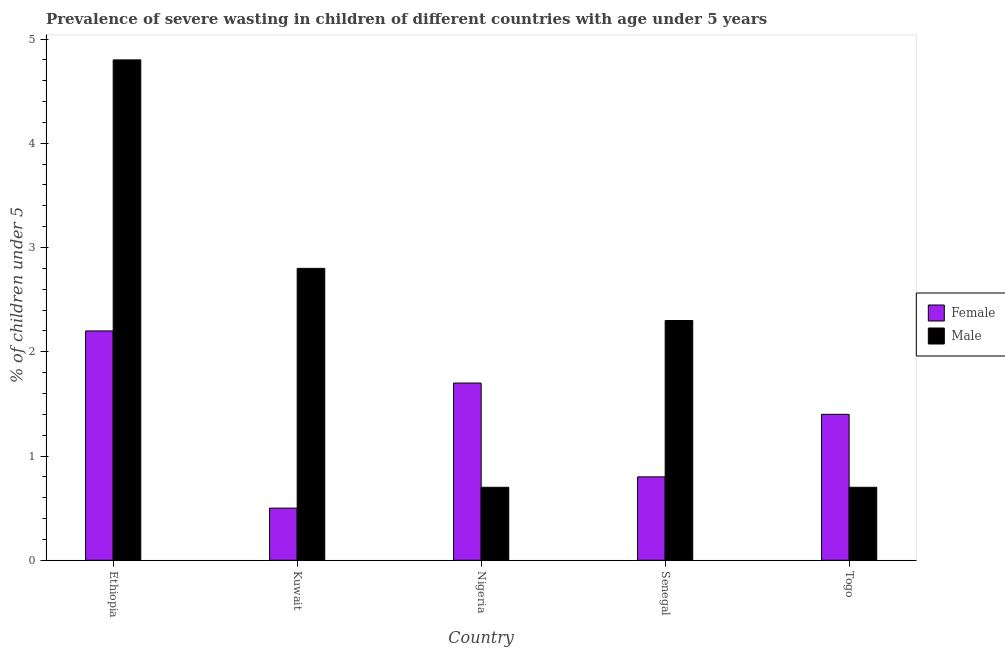How many different coloured bars are there?
Keep it short and to the point. 2. How many groups of bars are there?
Your answer should be compact. 5. Are the number of bars per tick equal to the number of legend labels?
Provide a short and direct response. Yes. How many bars are there on the 4th tick from the left?
Offer a terse response. 2. How many bars are there on the 1st tick from the right?
Provide a short and direct response. 2. What is the label of the 1st group of bars from the left?
Provide a succinct answer. Ethiopia. In how many cases, is the number of bars for a given country not equal to the number of legend labels?
Your answer should be compact. 0. What is the percentage of undernourished male children in Togo?
Your answer should be very brief. 0.7. Across all countries, what is the maximum percentage of undernourished male children?
Make the answer very short. 4.8. Across all countries, what is the minimum percentage of undernourished female children?
Give a very brief answer. 0.5. In which country was the percentage of undernourished male children maximum?
Give a very brief answer. Ethiopia. In which country was the percentage of undernourished female children minimum?
Provide a succinct answer. Kuwait. What is the total percentage of undernourished female children in the graph?
Ensure brevity in your answer.  6.6. What is the difference between the percentage of undernourished female children in Kuwait and the percentage of undernourished male children in Ethiopia?
Provide a succinct answer. -4.3. What is the average percentage of undernourished female children per country?
Give a very brief answer. 1.32. What is the difference between the percentage of undernourished male children and percentage of undernourished female children in Nigeria?
Your response must be concise. -1. In how many countries, is the percentage of undernourished female children greater than 4.2 %?
Ensure brevity in your answer.  0. What is the ratio of the percentage of undernourished male children in Nigeria to that in Senegal?
Provide a succinct answer. 0.3. Is the percentage of undernourished female children in Kuwait less than that in Togo?
Your answer should be compact. Yes. Is the difference between the percentage of undernourished male children in Senegal and Togo greater than the difference between the percentage of undernourished female children in Senegal and Togo?
Your response must be concise. Yes. What is the difference between the highest and the second highest percentage of undernourished male children?
Your answer should be very brief. 2. What is the difference between the highest and the lowest percentage of undernourished female children?
Give a very brief answer. 1.7. Is the sum of the percentage of undernourished female children in Senegal and Togo greater than the maximum percentage of undernourished male children across all countries?
Provide a succinct answer. No. What does the 2nd bar from the right in Ethiopia represents?
Offer a very short reply. Female. How many bars are there?
Provide a succinct answer. 10. How many countries are there in the graph?
Give a very brief answer. 5. Does the graph contain any zero values?
Make the answer very short. No. How many legend labels are there?
Make the answer very short. 2. How are the legend labels stacked?
Provide a succinct answer. Vertical. What is the title of the graph?
Your response must be concise. Prevalence of severe wasting in children of different countries with age under 5 years. Does "Commercial bank branches" appear as one of the legend labels in the graph?
Your answer should be very brief. No. What is the label or title of the X-axis?
Your response must be concise. Country. What is the label or title of the Y-axis?
Your answer should be compact.  % of children under 5. What is the  % of children under 5 of Female in Ethiopia?
Keep it short and to the point. 2.2. What is the  % of children under 5 in Male in Ethiopia?
Make the answer very short. 4.8. What is the  % of children under 5 in Female in Kuwait?
Provide a succinct answer. 0.5. What is the  % of children under 5 of Male in Kuwait?
Keep it short and to the point. 2.8. What is the  % of children under 5 in Female in Nigeria?
Offer a terse response. 1.7. What is the  % of children under 5 of Male in Nigeria?
Give a very brief answer. 0.7. What is the  % of children under 5 of Female in Senegal?
Ensure brevity in your answer.  0.8. What is the  % of children under 5 of Male in Senegal?
Provide a succinct answer. 2.3. What is the  % of children under 5 of Female in Togo?
Your answer should be very brief. 1.4. What is the  % of children under 5 in Male in Togo?
Offer a terse response. 0.7. Across all countries, what is the maximum  % of children under 5 in Female?
Offer a very short reply. 2.2. Across all countries, what is the maximum  % of children under 5 in Male?
Offer a very short reply. 4.8. Across all countries, what is the minimum  % of children under 5 in Male?
Provide a short and direct response. 0.7. What is the total  % of children under 5 of Male in the graph?
Your answer should be compact. 11.3. What is the difference between the  % of children under 5 in Female in Ethiopia and that in Kuwait?
Ensure brevity in your answer.  1.7. What is the difference between the  % of children under 5 of Male in Ethiopia and that in Kuwait?
Offer a very short reply. 2. What is the difference between the  % of children under 5 of Female in Ethiopia and that in Senegal?
Offer a very short reply. 1.4. What is the difference between the  % of children under 5 in Male in Ethiopia and that in Togo?
Offer a terse response. 4.1. What is the difference between the  % of children under 5 in Female in Kuwait and that in Nigeria?
Make the answer very short. -1.2. What is the difference between the  % of children under 5 of Male in Kuwait and that in Nigeria?
Your answer should be very brief. 2.1. What is the difference between the  % of children under 5 of Male in Kuwait and that in Senegal?
Your answer should be very brief. 0.5. What is the difference between the  % of children under 5 in Female in Kuwait and that in Togo?
Keep it short and to the point. -0.9. What is the difference between the  % of children under 5 of Male in Kuwait and that in Togo?
Your answer should be very brief. 2.1. What is the difference between the  % of children under 5 of Female in Nigeria and that in Togo?
Keep it short and to the point. 0.3. What is the difference between the  % of children under 5 in Female in Ethiopia and the  % of children under 5 in Male in Kuwait?
Offer a very short reply. -0.6. What is the difference between the  % of children under 5 in Female in Ethiopia and the  % of children under 5 in Male in Nigeria?
Your response must be concise. 1.5. What is the difference between the  % of children under 5 in Female in Ethiopia and the  % of children under 5 in Male in Senegal?
Your answer should be compact. -0.1. What is the difference between the  % of children under 5 of Female in Ethiopia and the  % of children under 5 of Male in Togo?
Make the answer very short. 1.5. What is the difference between the  % of children under 5 in Female in Kuwait and the  % of children under 5 in Male in Nigeria?
Make the answer very short. -0.2. What is the difference between the  % of children under 5 of Female in Kuwait and the  % of children under 5 of Male in Senegal?
Provide a short and direct response. -1.8. What is the difference between the  % of children under 5 of Female in Nigeria and the  % of children under 5 of Male in Senegal?
Give a very brief answer. -0.6. What is the difference between the  % of children under 5 of Female in Senegal and the  % of children under 5 of Male in Togo?
Provide a short and direct response. 0.1. What is the average  % of children under 5 of Female per country?
Keep it short and to the point. 1.32. What is the average  % of children under 5 in Male per country?
Give a very brief answer. 2.26. What is the ratio of the  % of children under 5 in Male in Ethiopia to that in Kuwait?
Ensure brevity in your answer.  1.71. What is the ratio of the  % of children under 5 in Female in Ethiopia to that in Nigeria?
Provide a short and direct response. 1.29. What is the ratio of the  % of children under 5 of Male in Ethiopia to that in Nigeria?
Give a very brief answer. 6.86. What is the ratio of the  % of children under 5 in Female in Ethiopia to that in Senegal?
Provide a succinct answer. 2.75. What is the ratio of the  % of children under 5 of Male in Ethiopia to that in Senegal?
Provide a short and direct response. 2.09. What is the ratio of the  % of children under 5 in Female in Ethiopia to that in Togo?
Provide a succinct answer. 1.57. What is the ratio of the  % of children under 5 in Male in Ethiopia to that in Togo?
Your response must be concise. 6.86. What is the ratio of the  % of children under 5 in Female in Kuwait to that in Nigeria?
Keep it short and to the point. 0.29. What is the ratio of the  % of children under 5 in Male in Kuwait to that in Nigeria?
Your answer should be compact. 4. What is the ratio of the  % of children under 5 in Female in Kuwait to that in Senegal?
Give a very brief answer. 0.62. What is the ratio of the  % of children under 5 of Male in Kuwait to that in Senegal?
Give a very brief answer. 1.22. What is the ratio of the  % of children under 5 of Female in Kuwait to that in Togo?
Offer a very short reply. 0.36. What is the ratio of the  % of children under 5 of Female in Nigeria to that in Senegal?
Provide a short and direct response. 2.12. What is the ratio of the  % of children under 5 of Male in Nigeria to that in Senegal?
Your answer should be very brief. 0.3. What is the ratio of the  % of children under 5 in Female in Nigeria to that in Togo?
Ensure brevity in your answer.  1.21. What is the ratio of the  % of children under 5 of Female in Senegal to that in Togo?
Provide a short and direct response. 0.57. What is the ratio of the  % of children under 5 in Male in Senegal to that in Togo?
Keep it short and to the point. 3.29. What is the difference between the highest and the lowest  % of children under 5 in Female?
Provide a succinct answer. 1.7. What is the difference between the highest and the lowest  % of children under 5 in Male?
Offer a very short reply. 4.1. 